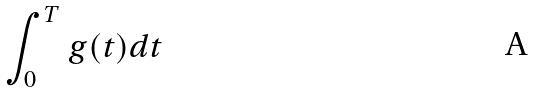Convert formula to latex. <formula><loc_0><loc_0><loc_500><loc_500>\int _ { 0 } ^ { T } g ( t ) d t</formula> 